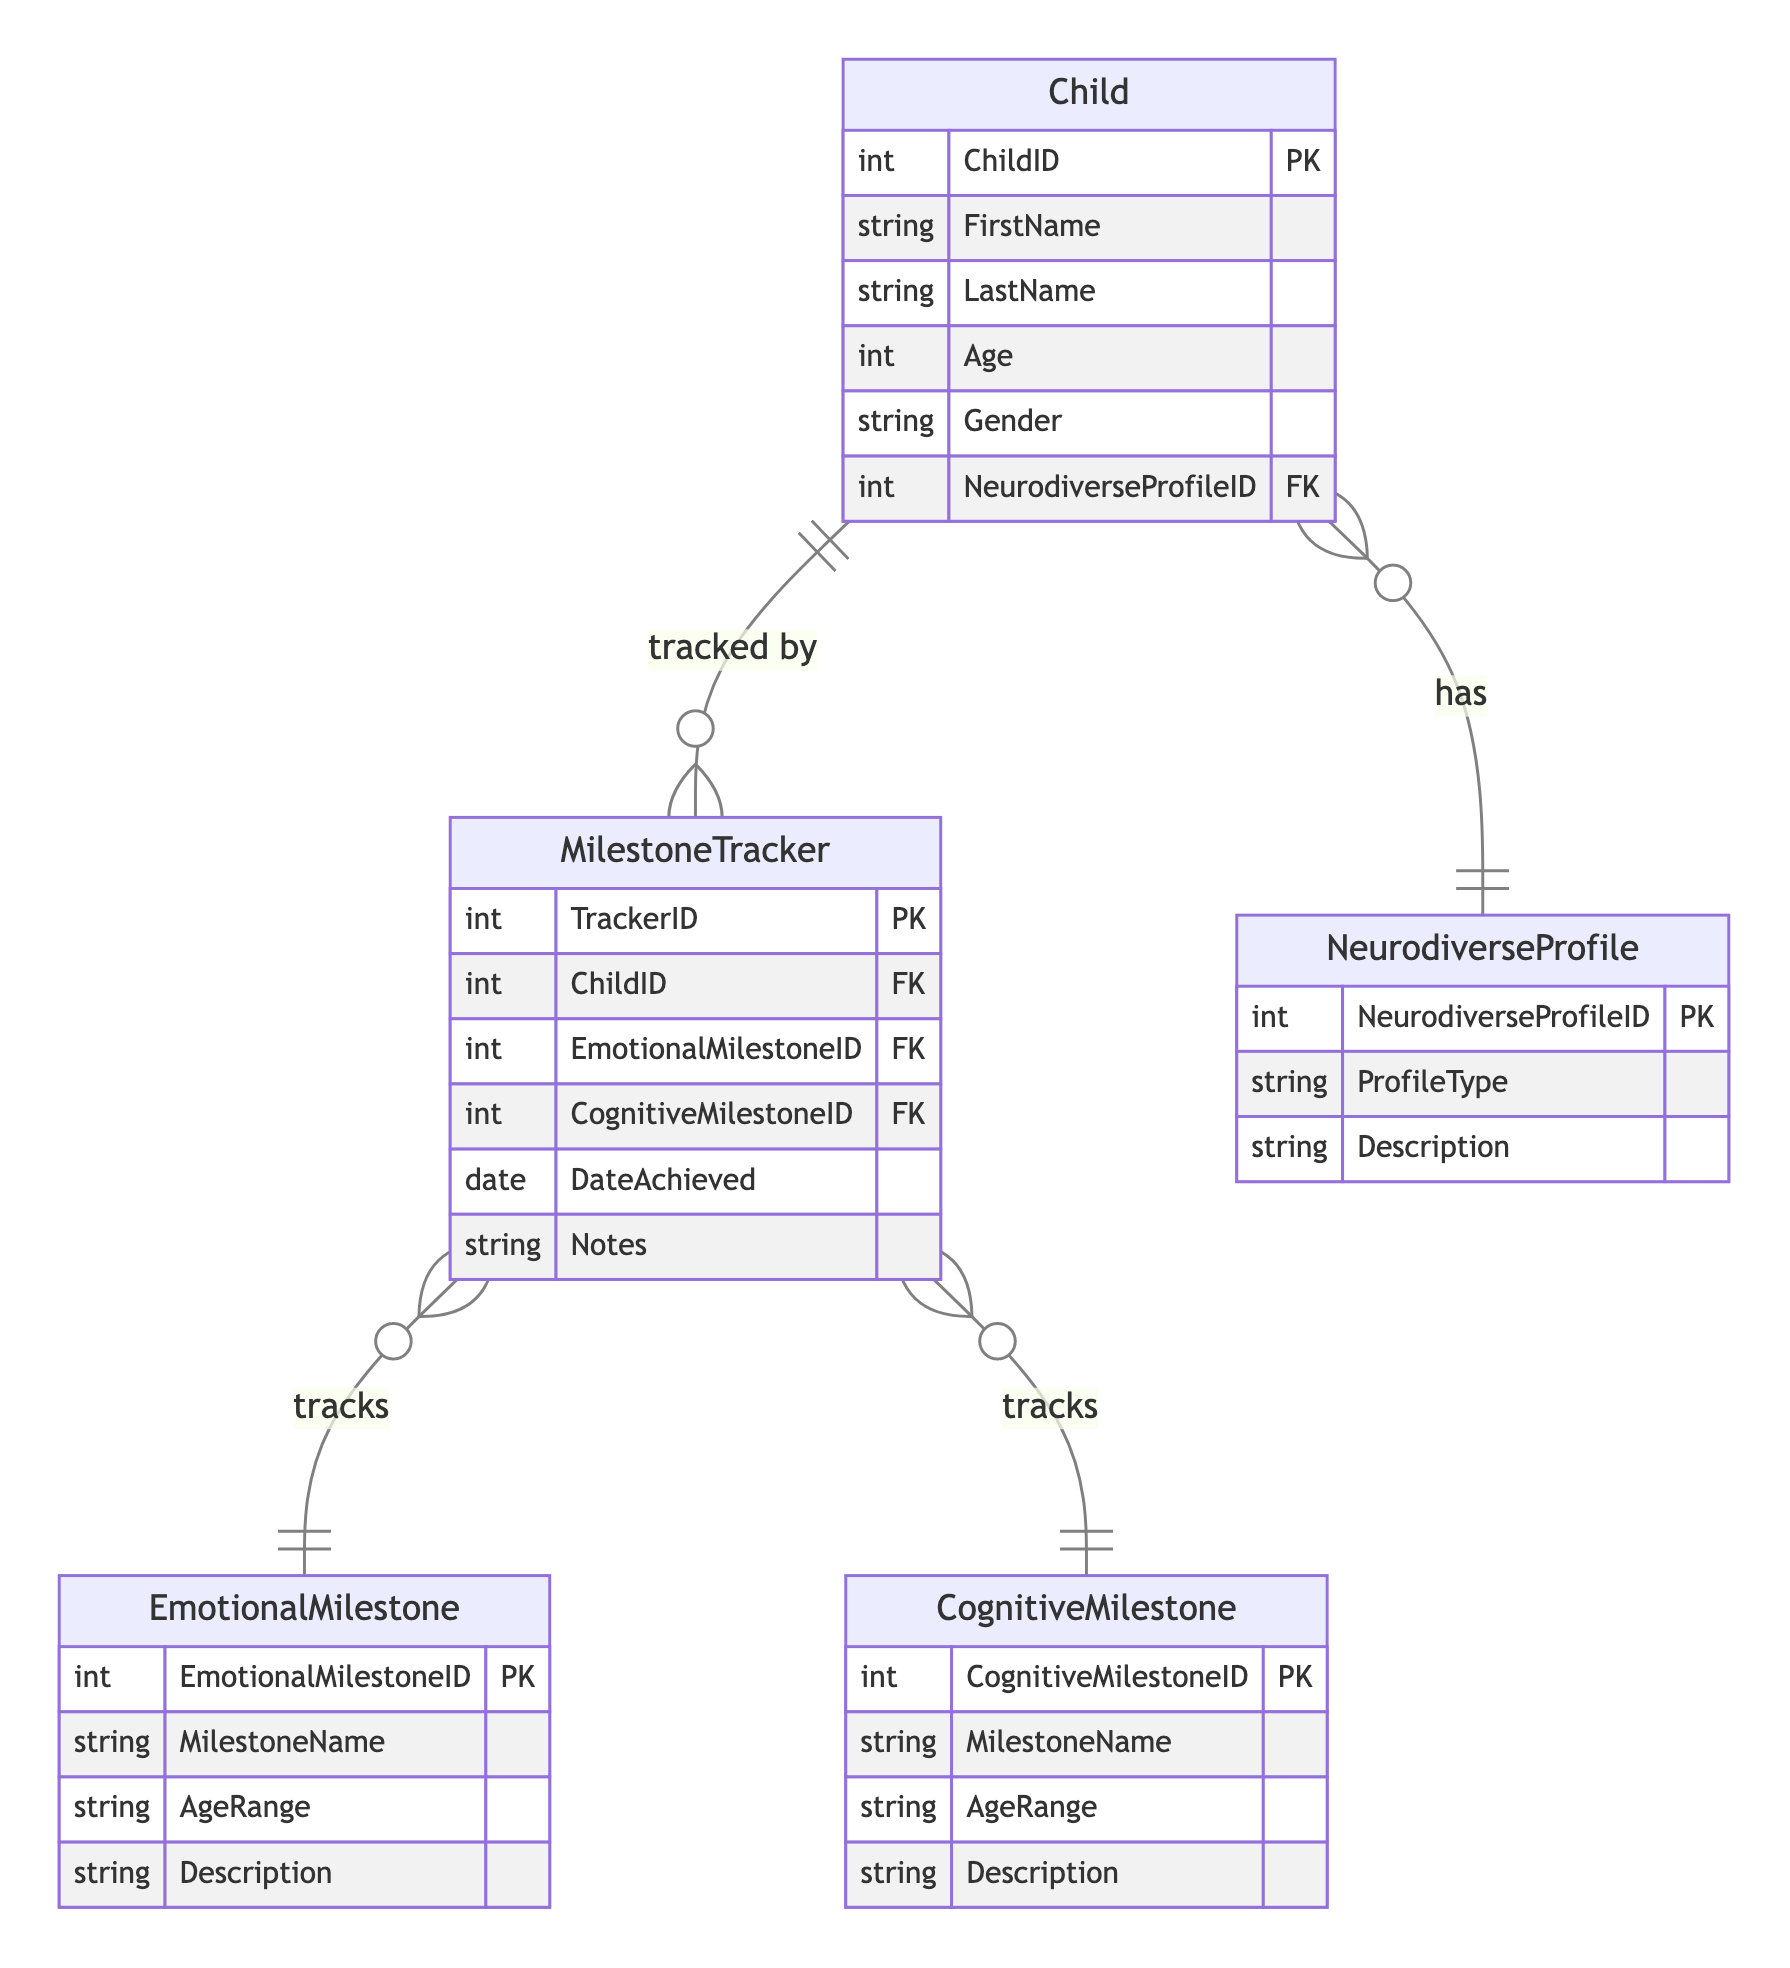What entity represents the emotional development of a child? The entity that denotes emotional development milestones is named "EmotionalMilestone." It is specifically designed to track various emotional milestones achieved by children.
Answer: EmotionalMilestone How many attributes does the Child entity have? The Child entity consists of six attributes: ChildID, FirstName, LastName, Age, Gender, and NeurodiverseProfileID. When counting these attributes, we arrive at the total number.
Answer: 6 What relationship exists between Child and NeurodiverseProfile? The relationship defined between Child and NeurodiverseProfile is a "OneToMany" relationship, meaning that a single NeurodiverseProfile can be associated with multiple Child records.
Answer: OneToMany What is the primary key of the MilestoneTracker entity? The primary key that uniquely identifies each record in the MilestoneTracker entity is TrackerID. This key is essential for differentiating each entry in the tracking records.
Answer: TrackerID Which entity tracks both emotional and cognitive milestones? The entity that captures both emotional and cognitive milestones is called MilestoneTracker. This entity maintains records of milestones for individual children.
Answer: MilestoneTracker How many different types of milestones can the MilestoneTracker track? The MilestoneTracker can track two different types of milestones: EmotionalMilestone and CognitiveMilestone. Collectively, they represent emotional and cognitive developments.
Answer: 2 What is the foreign key in the MilestoneTracker entity that relates to the Child entity? The foreign key in the MilestoneTracker that is related to the Child entity is ChildID. This association allows linking individual milestone tracking records back to specific children.
Answer: ChildID What is the relationship type between MilestoneTracker and EmotionalMilestone? The relationship between MilestoneTracker and EmotionalMilestone is noted as "ManyToOne." This implies that multiple tracking records can correspond to a single emotional milestone.
Answer: ManyToOne What attribute identifies a specific neurodiverse profile? The attribute that identifies each neurodiverse profile is NeurodiverseProfileID. This unique identifier allows for the classification of different neurodiverse profiles.
Answer: NeurodiverseProfileID 